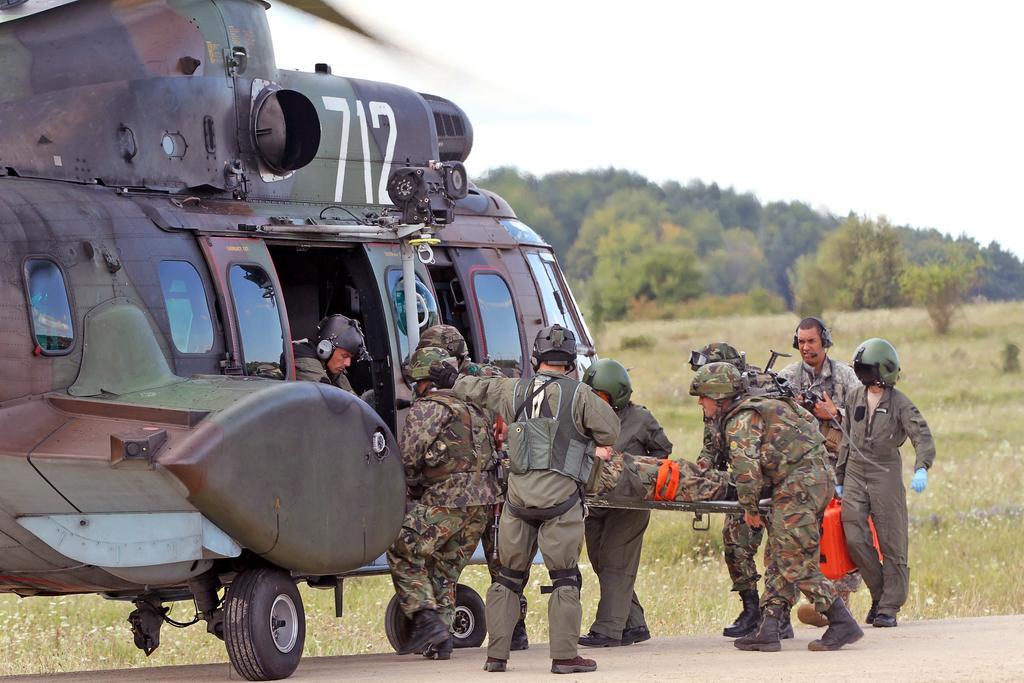Please provide a concise description of this image. In this picture, we see many military people carrying a man on the stretcher. Behind him, we see a man who is wearing a helmet is holding a red color suitcase in his hand. Beside them, we see a helicopter. Behind them, we see the grass and there are many trees in the background. At the top of the picture, we see the sky. 